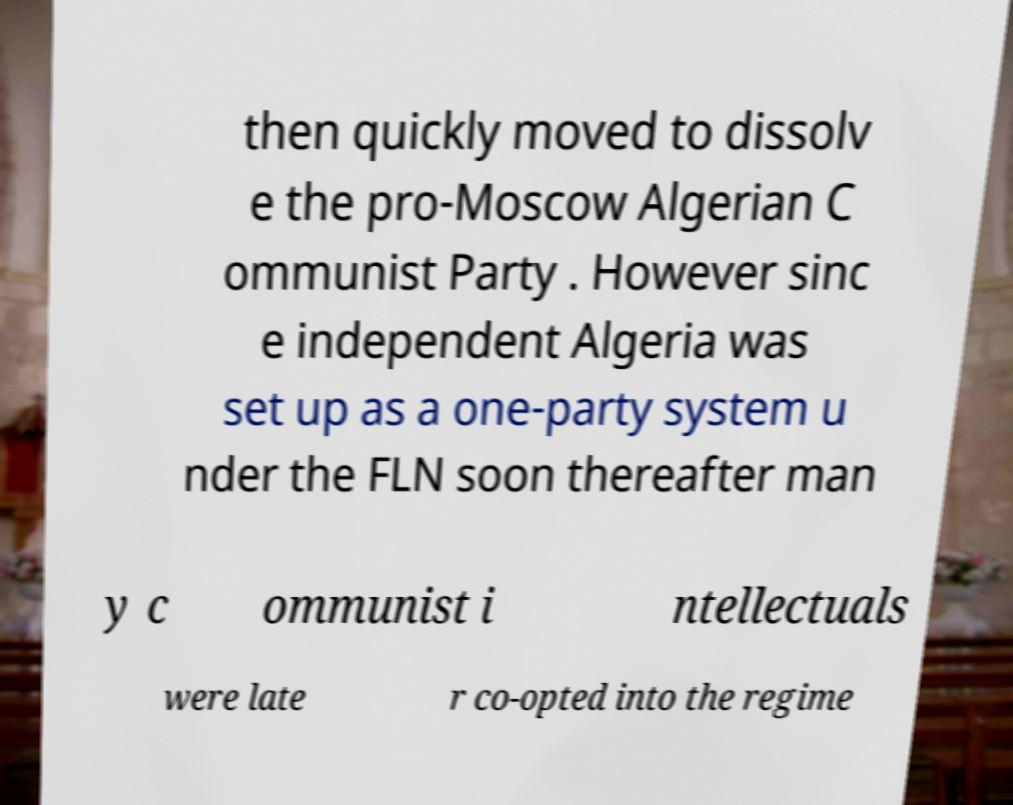Can you read and provide the text displayed in the image?This photo seems to have some interesting text. Can you extract and type it out for me? then quickly moved to dissolv e the pro-Moscow Algerian C ommunist Party . However sinc e independent Algeria was set up as a one-party system u nder the FLN soon thereafter man y c ommunist i ntellectuals were late r co-opted into the regime 